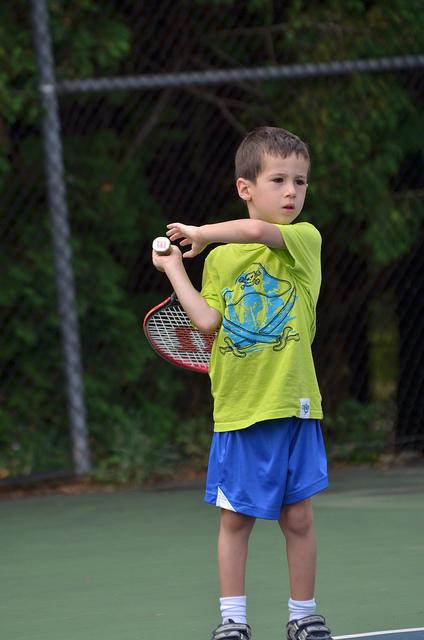What type of fence is in the picture?
Keep it brief. Wire. What color is that racket?
Give a very brief answer. Red. What color is the boys socks?
Be succinct. White. What color are the boy's shorts?
Be succinct. Blue. 